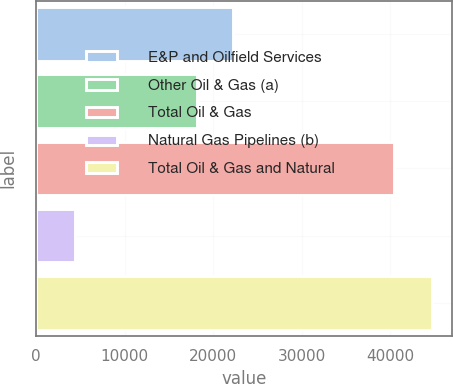Convert chart to OTSL. <chart><loc_0><loc_0><loc_500><loc_500><bar_chart><fcel>E&P and Oilfield Services<fcel>Other Oil & Gas (a)<fcel>Total Oil & Gas<fcel>Natural Gas Pipelines (b)<fcel>Total Oil & Gas and Natural<nl><fcel>22227<fcel>18140<fcel>40367<fcel>4359<fcel>44726<nl></chart> 